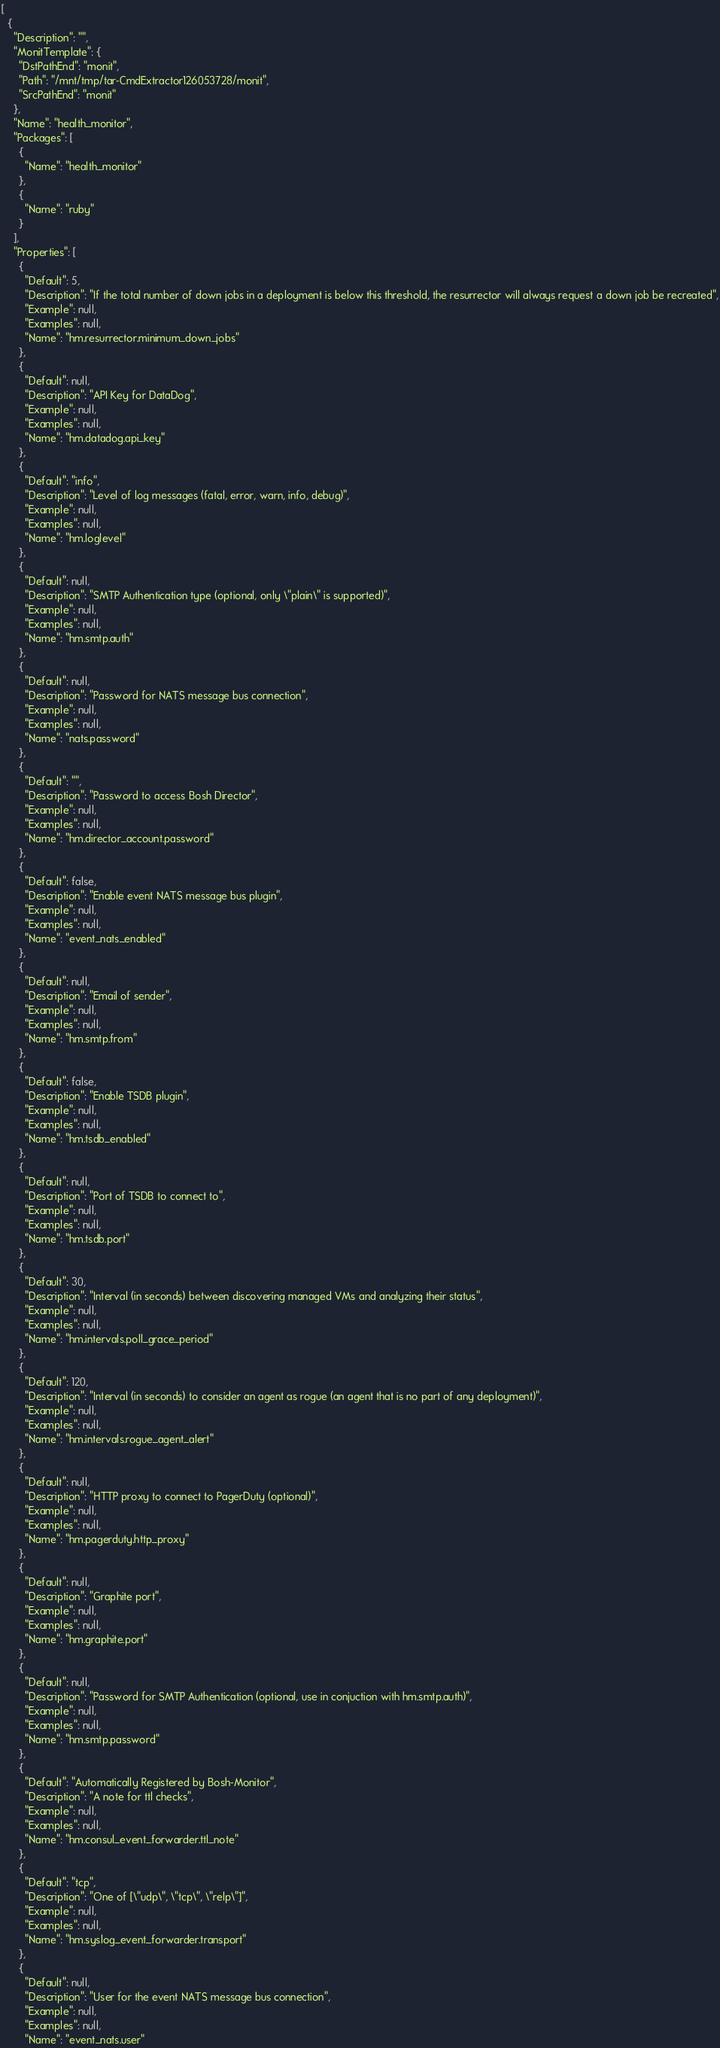Convert code to text. <code><loc_0><loc_0><loc_500><loc_500><_YAML_>[
  {
    "Description": "",
    "MonitTemplate": {
      "DstPathEnd": "monit",
      "Path": "/mnt/tmp/tar-CmdExtractor126053728/monit",
      "SrcPathEnd": "monit"
    },
    "Name": "health_monitor",
    "Packages": [
      {
        "Name": "health_monitor"
      },
      {
        "Name": "ruby"
      }
    ],
    "Properties": [
      {
        "Default": 5,
        "Description": "If the total number of down jobs in a deployment is below this threshold, the resurrector will always request a down job be recreated",
        "Example": null,
        "Examples": null,
        "Name": "hm.resurrector.minimum_down_jobs"
      },
      {
        "Default": null,
        "Description": "API Key for DataDog",
        "Example": null,
        "Examples": null,
        "Name": "hm.datadog.api_key"
      },
      {
        "Default": "info",
        "Description": "Level of log messages (fatal, error, warn, info, debug)",
        "Example": null,
        "Examples": null,
        "Name": "hm.loglevel"
      },
      {
        "Default": null,
        "Description": "SMTP Authentication type (optional, only \"plain\" is supported)",
        "Example": null,
        "Examples": null,
        "Name": "hm.smtp.auth"
      },
      {
        "Default": null,
        "Description": "Password for NATS message bus connection",
        "Example": null,
        "Examples": null,
        "Name": "nats.password"
      },
      {
        "Default": "",
        "Description": "Password to access Bosh Director",
        "Example": null,
        "Examples": null,
        "Name": "hm.director_account.password"
      },
      {
        "Default": false,
        "Description": "Enable event NATS message bus plugin",
        "Example": null,
        "Examples": null,
        "Name": "event_nats_enabled"
      },
      {
        "Default": null,
        "Description": "Email of sender",
        "Example": null,
        "Examples": null,
        "Name": "hm.smtp.from"
      },
      {
        "Default": false,
        "Description": "Enable TSDB plugin",
        "Example": null,
        "Examples": null,
        "Name": "hm.tsdb_enabled"
      },
      {
        "Default": null,
        "Description": "Port of TSDB to connect to",
        "Example": null,
        "Examples": null,
        "Name": "hm.tsdb.port"
      },
      {
        "Default": 30,
        "Description": "Interval (in seconds) between discovering managed VMs and analyzing their status",
        "Example": null,
        "Examples": null,
        "Name": "hm.intervals.poll_grace_period"
      },
      {
        "Default": 120,
        "Description": "Interval (in seconds) to consider an agent as rogue (an agent that is no part of any deployment)",
        "Example": null,
        "Examples": null,
        "Name": "hm.intervals.rogue_agent_alert"
      },
      {
        "Default": null,
        "Description": "HTTP proxy to connect to PagerDuty (optional)",
        "Example": null,
        "Examples": null,
        "Name": "hm.pagerduty.http_proxy"
      },
      {
        "Default": null,
        "Description": "Graphite port",
        "Example": null,
        "Examples": null,
        "Name": "hm.graphite.port"
      },
      {
        "Default": null,
        "Description": "Password for SMTP Authentication (optional, use in conjuction with hm.smtp.auth)",
        "Example": null,
        "Examples": null,
        "Name": "hm.smtp.password"
      },
      {
        "Default": "Automatically Registered by Bosh-Monitor",
        "Description": "A note for ttl checks",
        "Example": null,
        "Examples": null,
        "Name": "hm.consul_event_forwarder.ttl_note"
      },
      {
        "Default": "tcp",
        "Description": "One of [\"udp\", \"tcp\", \"relp\"]",
        "Example": null,
        "Examples": null,
        "Name": "hm.syslog_event_forwarder.transport"
      },
      {
        "Default": null,
        "Description": "User for the event NATS message bus connection",
        "Example": null,
        "Examples": null,
        "Name": "event_nats.user"</code> 